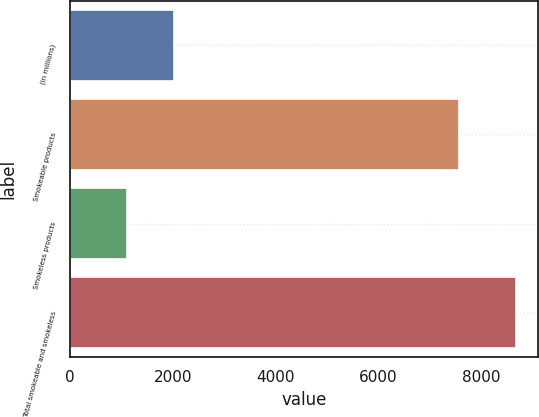<chart> <loc_0><loc_0><loc_500><loc_500><bar_chart><fcel>(in millions)<fcel>Smokeable products<fcel>Smokeless products<fcel>Total smokeable and smokeless<nl><fcel>2015<fcel>7569<fcel>1108<fcel>8677<nl></chart> 